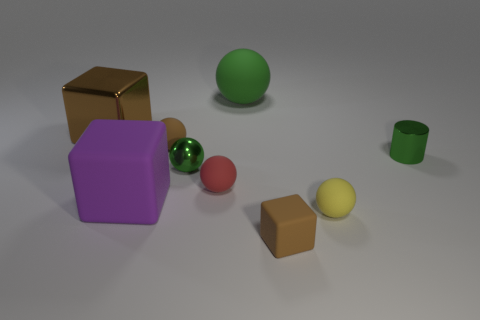What number of objects are either tiny spheres that are in front of the green metal sphere or big gray things?
Your answer should be compact. 2. How many other things are the same color as the small metallic cylinder?
Provide a short and direct response. 2. Do the metal sphere and the tiny metallic object to the right of the big green rubber thing have the same color?
Provide a succinct answer. Yes. There is another small thing that is the same shape as the purple thing; what color is it?
Give a very brief answer. Brown. Do the small yellow object and the small green thing to the right of the tiny block have the same material?
Your answer should be compact. No. What is the color of the small metallic sphere?
Make the answer very short. Green. There is a tiny metallic thing to the left of the small brown matte thing that is in front of the tiny metal thing to the right of the tiny brown rubber block; what is its color?
Provide a short and direct response. Green. There is a yellow rubber thing; is it the same shape as the small brown object left of the tiny brown rubber cube?
Your response must be concise. Yes. The big thing that is both right of the large metal thing and behind the cylinder is what color?
Make the answer very short. Green. Is there a rubber object that has the same shape as the large shiny thing?
Provide a short and direct response. Yes. 